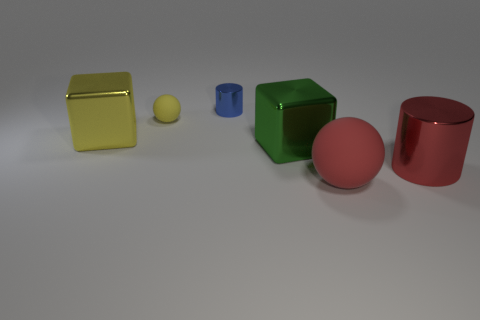What size is the yellow thing that is the same shape as the big red matte object?
Offer a very short reply. Small. Are there any big red cylinders that are behind the metal cube that is behind the green thing?
Offer a terse response. No. Does the tiny shiny object have the same color as the large rubber object?
Offer a terse response. No. What number of other things are there of the same shape as the tiny blue metallic thing?
Provide a succinct answer. 1. Are there more tiny blue objects that are to the right of the large red ball than large shiny blocks on the left side of the tiny sphere?
Your answer should be very brief. No. There is a cylinder in front of the large green metal thing; does it have the same size as the thing in front of the big red shiny cylinder?
Offer a very short reply. Yes. What shape is the large matte thing?
Give a very brief answer. Sphere. What is the size of the thing that is the same color as the tiny ball?
Provide a succinct answer. Large. What is the color of the big cylinder that is made of the same material as the tiny blue cylinder?
Your answer should be compact. Red. Does the big green object have the same material as the small object right of the small rubber ball?
Give a very brief answer. Yes. 